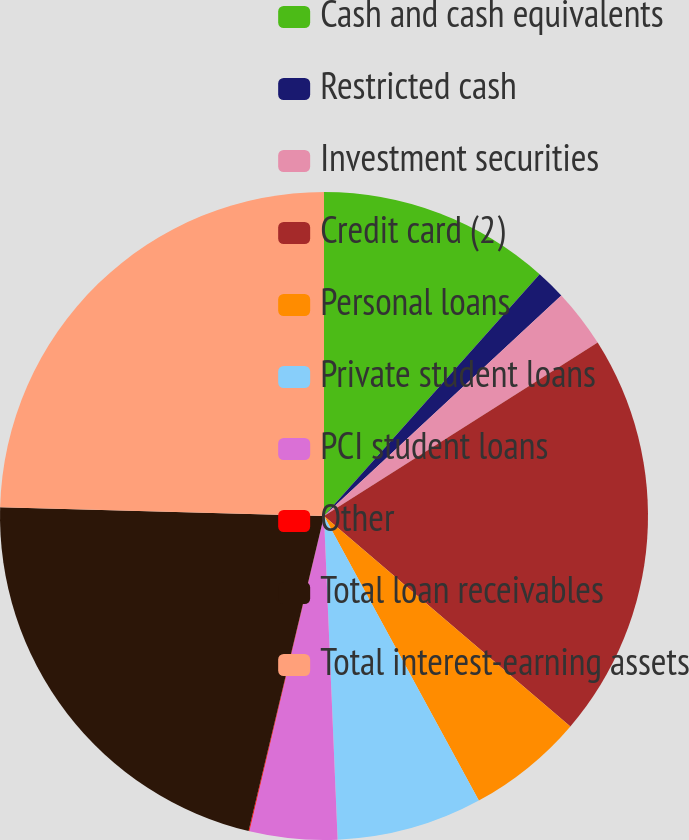<chart> <loc_0><loc_0><loc_500><loc_500><pie_chart><fcel>Cash and cash equivalents<fcel>Restricted cash<fcel>Investment securities<fcel>Credit card (2)<fcel>Personal loans<fcel>Private student loans<fcel>PCI student loans<fcel>Other<fcel>Total loan receivables<fcel>Total interest-earning assets<nl><fcel>11.59%<fcel>1.49%<fcel>2.93%<fcel>20.24%<fcel>5.82%<fcel>7.26%<fcel>4.37%<fcel>0.04%<fcel>21.69%<fcel>24.57%<nl></chart> 